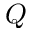Convert formula to latex. <formula><loc_0><loc_0><loc_500><loc_500>Q</formula> 